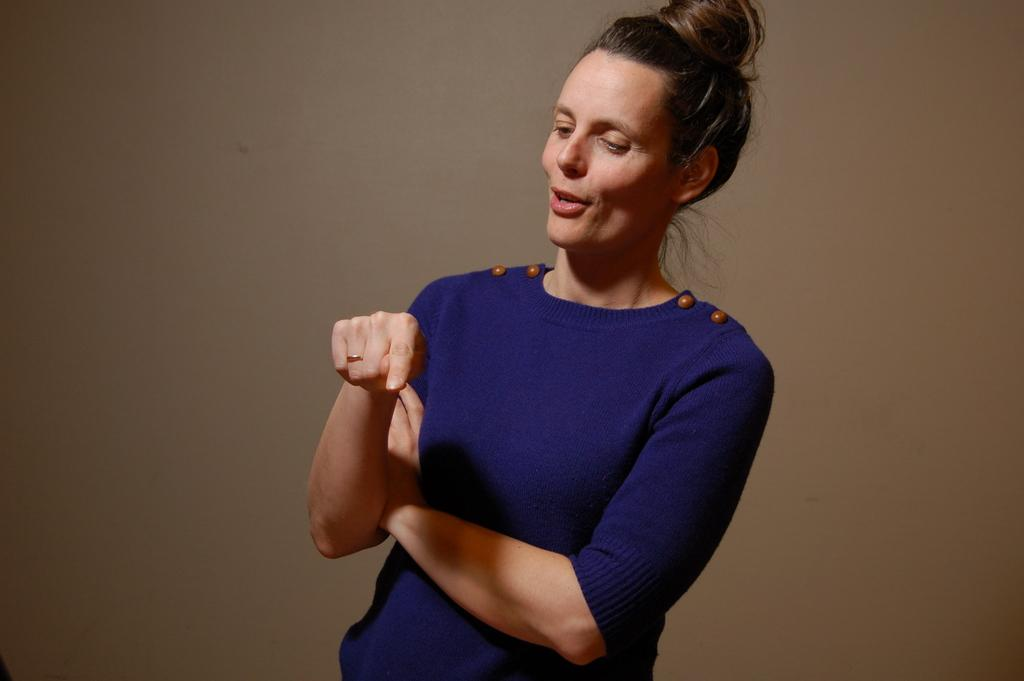Who is the main subject in the image? There is a woman in the center of the image. What can be seen in the background of the image? There is a wall in the background of the image. What type of tent is set up near the woman in the image? There is no tent present in the image. Can you see any bats flying around the woman in the image? There are no bats visible in the image. 